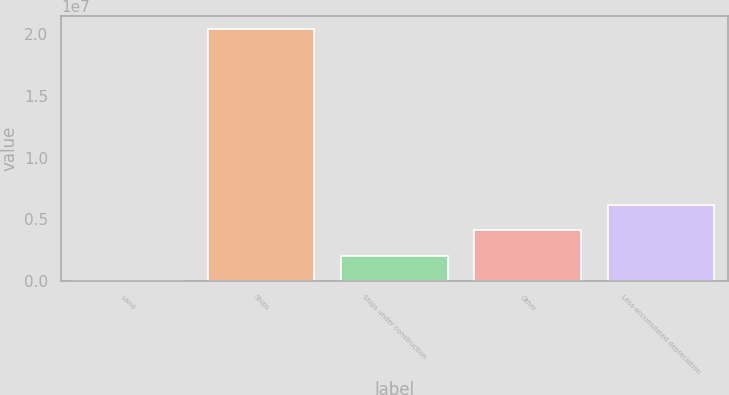<chart> <loc_0><loc_0><loc_500><loc_500><bar_chart><fcel>Land<fcel>Ships<fcel>Ships under construction<fcel>Other<fcel>Less-accumulated depreciation<nl><fcel>16688<fcel>2.0455e+07<fcel>2.06052e+06<fcel>4.10434e+06<fcel>6.14817e+06<nl></chart> 